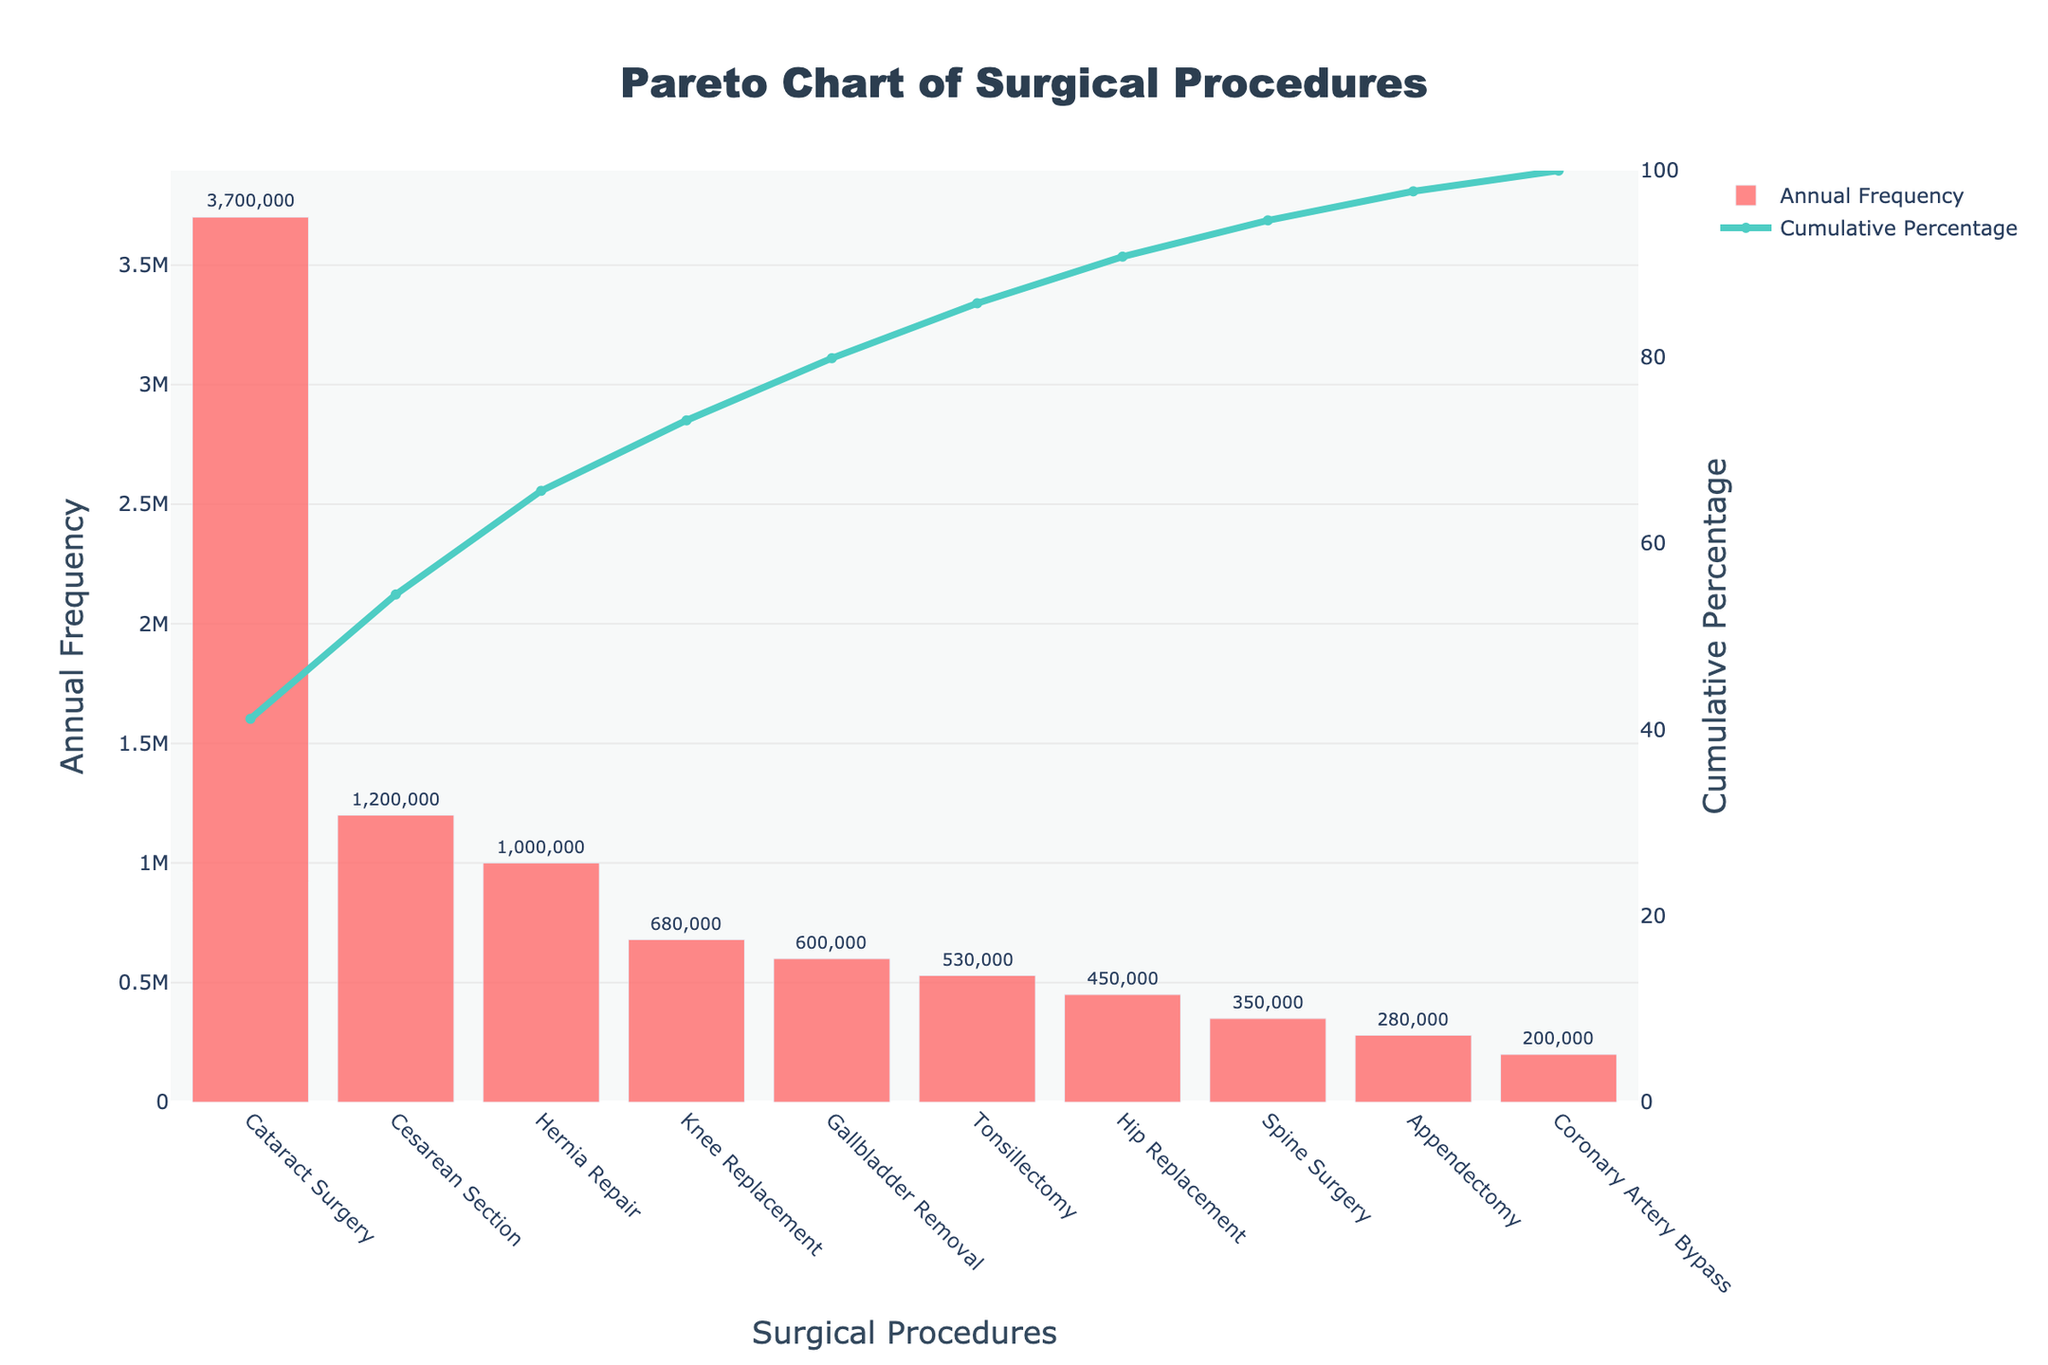What is the most common surgical procedure performed annually? The bar chart shows the "Cataract Surgery" has the highest bar among all procedures indicating the highest annual frequency. Also, the cumulative percentage line has the steepest initial rise at this procedure.
Answer: Cataract Surgery What is the title of the figure? The title is displayed at the top of the Pareto chart. It provides a brief description of the entire chart.
Answer: Pareto Chart of Surgical Procedures Which surgical procedure has the lowest annual frequency according to the chart? By looking at the shortest bar in the bar chart, "Coronary Artery Bypass" is identified as the procedure with the lowest annual frequency.
Answer: Coronary Artery Bypass What is the cumulative percentage of the three most common procedures? The cumulative percentage of the first three procedures (Cataract Surgery, Cesarean Section, and Hernia Repair) can be read directly from the line chart. It shows a value around 74%.
Answer: Approximately 74% Identify the procedure with an annual frequency of around 600,000. The procedure closest to the 600,000 mark can be found by locating the bar that extends to approximately this value on the chart. "Gallbladder Removal" is positioned around this frequency.
Answer: Gallbladder Removal How does the annual frequency of Hip Replacement compare to Knee Replacement? By comparing the bar heights for Hip Replacement and Knee Replacement procedures, Knee Replacement has a higher annual frequency.
Answer: Knee Replacement has a higher frequency What is the cumulative percentage after the first five procedures? Observe the cumulative percentage line after the fifth procedure (Gallbladder Removal) which is near 88%.
Answer: Approximately 88% How many procedures cumulatively exceed 50% of the total frequency? The point at which the cumulative percentage line crosses the 50% mark is after the second procedure, Cesarean Section. So, two procedures exceed 50%.
Answer: 2 If we add the frequencies of hip replacement and tonsillectomy, what do we get? Adding the frequencies of Hip Replacement (450,000) and Tonsillectomy (530,000) yields 450,000 + 530,000 = 980,000.
Answer: 980,000 Which procedure has an annual frequency closer to 200,000? By examining the bar closest to the 200,000 mark, "Coronary Artery Bypass" fits this criterion.
Answer: Coronary Artery Bypass 